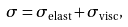Convert formula to latex. <formula><loc_0><loc_0><loc_500><loc_500>\sigma = \sigma _ { \text {elast} } + \sigma _ { \text {visc} } ,</formula> 